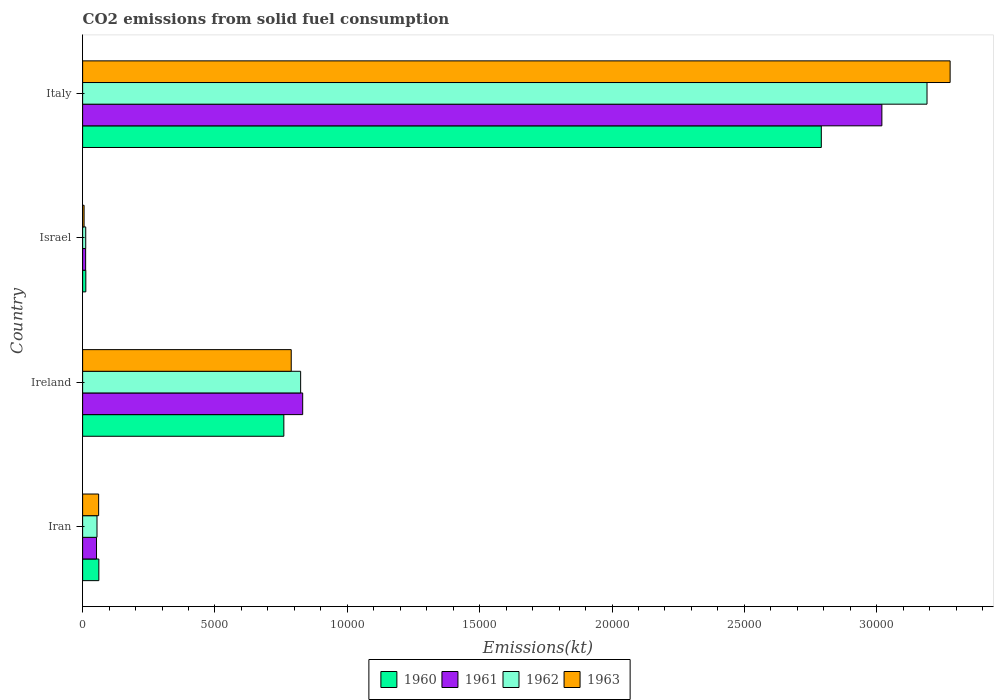How many groups of bars are there?
Your answer should be compact. 4. How many bars are there on the 3rd tick from the top?
Provide a short and direct response. 4. How many bars are there on the 1st tick from the bottom?
Provide a succinct answer. 4. In how many cases, is the number of bars for a given country not equal to the number of legend labels?
Provide a short and direct response. 0. What is the amount of CO2 emitted in 1961 in Ireland?
Make the answer very short. 8313.09. Across all countries, what is the maximum amount of CO2 emitted in 1961?
Offer a terse response. 3.02e+04. Across all countries, what is the minimum amount of CO2 emitted in 1963?
Your answer should be compact. 55.01. What is the total amount of CO2 emitted in 1963 in the graph?
Make the answer very short. 4.13e+04. What is the difference between the amount of CO2 emitted in 1963 in Ireland and that in Israel?
Keep it short and to the point. 7825.38. What is the difference between the amount of CO2 emitted in 1960 in Ireland and the amount of CO2 emitted in 1962 in Israel?
Offer a very short reply. 7484.35. What is the average amount of CO2 emitted in 1963 per country?
Provide a short and direct response. 1.03e+04. What is the difference between the amount of CO2 emitted in 1961 and amount of CO2 emitted in 1963 in Ireland?
Make the answer very short. 432.71. What is the ratio of the amount of CO2 emitted in 1961 in Iran to that in Israel?
Ensure brevity in your answer.  4.61. Is the amount of CO2 emitted in 1960 in Iran less than that in Israel?
Offer a very short reply. No. What is the difference between the highest and the second highest amount of CO2 emitted in 1962?
Ensure brevity in your answer.  2.37e+04. What is the difference between the highest and the lowest amount of CO2 emitted in 1962?
Keep it short and to the point. 3.18e+04. In how many countries, is the amount of CO2 emitted in 1962 greater than the average amount of CO2 emitted in 1962 taken over all countries?
Your answer should be compact. 1. Is the sum of the amount of CO2 emitted in 1961 in Israel and Italy greater than the maximum amount of CO2 emitted in 1962 across all countries?
Your answer should be compact. No. How many bars are there?
Give a very brief answer. 16. What is the difference between two consecutive major ticks on the X-axis?
Keep it short and to the point. 5000. Does the graph contain grids?
Give a very brief answer. No. Where does the legend appear in the graph?
Your answer should be very brief. Bottom center. How many legend labels are there?
Your answer should be very brief. 4. What is the title of the graph?
Keep it short and to the point. CO2 emissions from solid fuel consumption. Does "2013" appear as one of the legend labels in the graph?
Offer a very short reply. No. What is the label or title of the X-axis?
Provide a short and direct response. Emissions(kt). What is the Emissions(kt) in 1960 in Iran?
Your answer should be compact. 612.39. What is the Emissions(kt) in 1961 in Iran?
Your response must be concise. 524.38. What is the Emissions(kt) of 1962 in Iran?
Provide a short and direct response. 542.72. What is the Emissions(kt) in 1963 in Iran?
Keep it short and to the point. 605.05. What is the Emissions(kt) of 1960 in Ireland?
Offer a very short reply. 7601.69. What is the Emissions(kt) of 1961 in Ireland?
Your answer should be compact. 8313.09. What is the Emissions(kt) of 1962 in Ireland?
Your answer should be very brief. 8236.08. What is the Emissions(kt) of 1963 in Ireland?
Provide a short and direct response. 7880.38. What is the Emissions(kt) in 1960 in Israel?
Provide a succinct answer. 121.01. What is the Emissions(kt) of 1961 in Israel?
Provide a succinct answer. 113.68. What is the Emissions(kt) in 1962 in Israel?
Your answer should be very brief. 117.34. What is the Emissions(kt) of 1963 in Israel?
Your response must be concise. 55.01. What is the Emissions(kt) in 1960 in Italy?
Your answer should be very brief. 2.79e+04. What is the Emissions(kt) of 1961 in Italy?
Offer a terse response. 3.02e+04. What is the Emissions(kt) in 1962 in Italy?
Ensure brevity in your answer.  3.19e+04. What is the Emissions(kt) of 1963 in Italy?
Offer a terse response. 3.28e+04. Across all countries, what is the maximum Emissions(kt) of 1960?
Your answer should be compact. 2.79e+04. Across all countries, what is the maximum Emissions(kt) in 1961?
Give a very brief answer. 3.02e+04. Across all countries, what is the maximum Emissions(kt) in 1962?
Provide a succinct answer. 3.19e+04. Across all countries, what is the maximum Emissions(kt) of 1963?
Keep it short and to the point. 3.28e+04. Across all countries, what is the minimum Emissions(kt) in 1960?
Ensure brevity in your answer.  121.01. Across all countries, what is the minimum Emissions(kt) in 1961?
Your answer should be very brief. 113.68. Across all countries, what is the minimum Emissions(kt) of 1962?
Offer a terse response. 117.34. Across all countries, what is the minimum Emissions(kt) of 1963?
Your answer should be compact. 55.01. What is the total Emissions(kt) in 1960 in the graph?
Provide a succinct answer. 3.62e+04. What is the total Emissions(kt) in 1961 in the graph?
Ensure brevity in your answer.  3.91e+04. What is the total Emissions(kt) of 1962 in the graph?
Make the answer very short. 4.08e+04. What is the total Emissions(kt) of 1963 in the graph?
Your answer should be very brief. 4.13e+04. What is the difference between the Emissions(kt) of 1960 in Iran and that in Ireland?
Your response must be concise. -6989.3. What is the difference between the Emissions(kt) of 1961 in Iran and that in Ireland?
Ensure brevity in your answer.  -7788.71. What is the difference between the Emissions(kt) of 1962 in Iran and that in Ireland?
Make the answer very short. -7693.37. What is the difference between the Emissions(kt) of 1963 in Iran and that in Ireland?
Give a very brief answer. -7275.33. What is the difference between the Emissions(kt) in 1960 in Iran and that in Israel?
Ensure brevity in your answer.  491.38. What is the difference between the Emissions(kt) of 1961 in Iran and that in Israel?
Ensure brevity in your answer.  410.7. What is the difference between the Emissions(kt) of 1962 in Iran and that in Israel?
Your answer should be compact. 425.37. What is the difference between the Emissions(kt) in 1963 in Iran and that in Israel?
Your answer should be very brief. 550.05. What is the difference between the Emissions(kt) of 1960 in Iran and that in Italy?
Your response must be concise. -2.73e+04. What is the difference between the Emissions(kt) of 1961 in Iran and that in Italy?
Ensure brevity in your answer.  -2.97e+04. What is the difference between the Emissions(kt) of 1962 in Iran and that in Italy?
Offer a terse response. -3.14e+04. What is the difference between the Emissions(kt) of 1963 in Iran and that in Italy?
Provide a succinct answer. -3.22e+04. What is the difference between the Emissions(kt) in 1960 in Ireland and that in Israel?
Give a very brief answer. 7480.68. What is the difference between the Emissions(kt) in 1961 in Ireland and that in Israel?
Keep it short and to the point. 8199.41. What is the difference between the Emissions(kt) of 1962 in Ireland and that in Israel?
Give a very brief answer. 8118.74. What is the difference between the Emissions(kt) of 1963 in Ireland and that in Israel?
Your response must be concise. 7825.38. What is the difference between the Emissions(kt) of 1960 in Ireland and that in Italy?
Ensure brevity in your answer.  -2.03e+04. What is the difference between the Emissions(kt) in 1961 in Ireland and that in Italy?
Keep it short and to the point. -2.19e+04. What is the difference between the Emissions(kt) of 1962 in Ireland and that in Italy?
Offer a terse response. -2.37e+04. What is the difference between the Emissions(kt) in 1963 in Ireland and that in Italy?
Offer a very short reply. -2.49e+04. What is the difference between the Emissions(kt) in 1960 in Israel and that in Italy?
Your answer should be compact. -2.78e+04. What is the difference between the Emissions(kt) of 1961 in Israel and that in Italy?
Make the answer very short. -3.01e+04. What is the difference between the Emissions(kt) in 1962 in Israel and that in Italy?
Make the answer very short. -3.18e+04. What is the difference between the Emissions(kt) in 1963 in Israel and that in Italy?
Provide a short and direct response. -3.27e+04. What is the difference between the Emissions(kt) in 1960 in Iran and the Emissions(kt) in 1961 in Ireland?
Your answer should be compact. -7700.7. What is the difference between the Emissions(kt) in 1960 in Iran and the Emissions(kt) in 1962 in Ireland?
Make the answer very short. -7623.69. What is the difference between the Emissions(kt) in 1960 in Iran and the Emissions(kt) in 1963 in Ireland?
Make the answer very short. -7267.99. What is the difference between the Emissions(kt) of 1961 in Iran and the Emissions(kt) of 1962 in Ireland?
Provide a short and direct response. -7711.7. What is the difference between the Emissions(kt) in 1961 in Iran and the Emissions(kt) in 1963 in Ireland?
Ensure brevity in your answer.  -7356. What is the difference between the Emissions(kt) of 1962 in Iran and the Emissions(kt) of 1963 in Ireland?
Your response must be concise. -7337.67. What is the difference between the Emissions(kt) of 1960 in Iran and the Emissions(kt) of 1961 in Israel?
Offer a terse response. 498.71. What is the difference between the Emissions(kt) of 1960 in Iran and the Emissions(kt) of 1962 in Israel?
Provide a succinct answer. 495.05. What is the difference between the Emissions(kt) of 1960 in Iran and the Emissions(kt) of 1963 in Israel?
Your answer should be very brief. 557.38. What is the difference between the Emissions(kt) in 1961 in Iran and the Emissions(kt) in 1962 in Israel?
Ensure brevity in your answer.  407.04. What is the difference between the Emissions(kt) of 1961 in Iran and the Emissions(kt) of 1963 in Israel?
Ensure brevity in your answer.  469.38. What is the difference between the Emissions(kt) in 1962 in Iran and the Emissions(kt) in 1963 in Israel?
Offer a very short reply. 487.71. What is the difference between the Emissions(kt) of 1960 in Iran and the Emissions(kt) of 1961 in Italy?
Your response must be concise. -2.96e+04. What is the difference between the Emissions(kt) in 1960 in Iran and the Emissions(kt) in 1962 in Italy?
Provide a short and direct response. -3.13e+04. What is the difference between the Emissions(kt) in 1960 in Iran and the Emissions(kt) in 1963 in Italy?
Ensure brevity in your answer.  -3.22e+04. What is the difference between the Emissions(kt) in 1961 in Iran and the Emissions(kt) in 1962 in Italy?
Keep it short and to the point. -3.14e+04. What is the difference between the Emissions(kt) of 1961 in Iran and the Emissions(kt) of 1963 in Italy?
Give a very brief answer. -3.22e+04. What is the difference between the Emissions(kt) of 1962 in Iran and the Emissions(kt) of 1963 in Italy?
Your answer should be compact. -3.22e+04. What is the difference between the Emissions(kt) of 1960 in Ireland and the Emissions(kt) of 1961 in Israel?
Your answer should be very brief. 7488.01. What is the difference between the Emissions(kt) of 1960 in Ireland and the Emissions(kt) of 1962 in Israel?
Offer a very short reply. 7484.35. What is the difference between the Emissions(kt) in 1960 in Ireland and the Emissions(kt) in 1963 in Israel?
Give a very brief answer. 7546.69. What is the difference between the Emissions(kt) of 1961 in Ireland and the Emissions(kt) of 1962 in Israel?
Offer a terse response. 8195.75. What is the difference between the Emissions(kt) in 1961 in Ireland and the Emissions(kt) in 1963 in Israel?
Provide a succinct answer. 8258.08. What is the difference between the Emissions(kt) in 1962 in Ireland and the Emissions(kt) in 1963 in Israel?
Your response must be concise. 8181.08. What is the difference between the Emissions(kt) in 1960 in Ireland and the Emissions(kt) in 1961 in Italy?
Offer a very short reply. -2.26e+04. What is the difference between the Emissions(kt) of 1960 in Ireland and the Emissions(kt) of 1962 in Italy?
Your response must be concise. -2.43e+04. What is the difference between the Emissions(kt) of 1960 in Ireland and the Emissions(kt) of 1963 in Italy?
Keep it short and to the point. -2.52e+04. What is the difference between the Emissions(kt) of 1961 in Ireland and the Emissions(kt) of 1962 in Italy?
Provide a succinct answer. -2.36e+04. What is the difference between the Emissions(kt) in 1961 in Ireland and the Emissions(kt) in 1963 in Italy?
Your response must be concise. -2.45e+04. What is the difference between the Emissions(kt) of 1962 in Ireland and the Emissions(kt) of 1963 in Italy?
Your answer should be compact. -2.45e+04. What is the difference between the Emissions(kt) in 1960 in Israel and the Emissions(kt) in 1961 in Italy?
Your response must be concise. -3.01e+04. What is the difference between the Emissions(kt) of 1960 in Israel and the Emissions(kt) of 1962 in Italy?
Your answer should be compact. -3.18e+04. What is the difference between the Emissions(kt) in 1960 in Israel and the Emissions(kt) in 1963 in Italy?
Your response must be concise. -3.27e+04. What is the difference between the Emissions(kt) of 1961 in Israel and the Emissions(kt) of 1962 in Italy?
Ensure brevity in your answer.  -3.18e+04. What is the difference between the Emissions(kt) of 1961 in Israel and the Emissions(kt) of 1963 in Italy?
Provide a short and direct response. -3.27e+04. What is the difference between the Emissions(kt) in 1962 in Israel and the Emissions(kt) in 1963 in Italy?
Provide a short and direct response. -3.27e+04. What is the average Emissions(kt) in 1960 per country?
Give a very brief answer. 9060.24. What is the average Emissions(kt) in 1961 per country?
Your response must be concise. 9786.31. What is the average Emissions(kt) in 1962 per country?
Provide a short and direct response. 1.02e+04. What is the average Emissions(kt) of 1963 per country?
Your response must be concise. 1.03e+04. What is the difference between the Emissions(kt) of 1960 and Emissions(kt) of 1961 in Iran?
Provide a succinct answer. 88.01. What is the difference between the Emissions(kt) in 1960 and Emissions(kt) in 1962 in Iran?
Your answer should be very brief. 69.67. What is the difference between the Emissions(kt) in 1960 and Emissions(kt) in 1963 in Iran?
Offer a terse response. 7.33. What is the difference between the Emissions(kt) in 1961 and Emissions(kt) in 1962 in Iran?
Ensure brevity in your answer.  -18.34. What is the difference between the Emissions(kt) in 1961 and Emissions(kt) in 1963 in Iran?
Ensure brevity in your answer.  -80.67. What is the difference between the Emissions(kt) in 1962 and Emissions(kt) in 1963 in Iran?
Offer a very short reply. -62.34. What is the difference between the Emissions(kt) in 1960 and Emissions(kt) in 1961 in Ireland?
Offer a very short reply. -711.4. What is the difference between the Emissions(kt) in 1960 and Emissions(kt) in 1962 in Ireland?
Offer a very short reply. -634.39. What is the difference between the Emissions(kt) in 1960 and Emissions(kt) in 1963 in Ireland?
Provide a succinct answer. -278.69. What is the difference between the Emissions(kt) of 1961 and Emissions(kt) of 1962 in Ireland?
Provide a short and direct response. 77.01. What is the difference between the Emissions(kt) of 1961 and Emissions(kt) of 1963 in Ireland?
Offer a very short reply. 432.71. What is the difference between the Emissions(kt) of 1962 and Emissions(kt) of 1963 in Ireland?
Make the answer very short. 355.7. What is the difference between the Emissions(kt) of 1960 and Emissions(kt) of 1961 in Israel?
Provide a succinct answer. 7.33. What is the difference between the Emissions(kt) in 1960 and Emissions(kt) in 1962 in Israel?
Your answer should be compact. 3.67. What is the difference between the Emissions(kt) in 1960 and Emissions(kt) in 1963 in Israel?
Make the answer very short. 66.01. What is the difference between the Emissions(kt) of 1961 and Emissions(kt) of 1962 in Israel?
Provide a succinct answer. -3.67. What is the difference between the Emissions(kt) in 1961 and Emissions(kt) in 1963 in Israel?
Provide a succinct answer. 58.67. What is the difference between the Emissions(kt) of 1962 and Emissions(kt) of 1963 in Israel?
Offer a very short reply. 62.34. What is the difference between the Emissions(kt) in 1960 and Emissions(kt) in 1961 in Italy?
Your answer should be very brief. -2288.21. What is the difference between the Emissions(kt) in 1960 and Emissions(kt) in 1962 in Italy?
Offer a terse response. -3993.36. What is the difference between the Emissions(kt) in 1960 and Emissions(kt) in 1963 in Italy?
Offer a very short reply. -4866.11. What is the difference between the Emissions(kt) of 1961 and Emissions(kt) of 1962 in Italy?
Your answer should be compact. -1705.15. What is the difference between the Emissions(kt) in 1961 and Emissions(kt) in 1963 in Italy?
Ensure brevity in your answer.  -2577.9. What is the difference between the Emissions(kt) in 1962 and Emissions(kt) in 1963 in Italy?
Offer a terse response. -872.75. What is the ratio of the Emissions(kt) in 1960 in Iran to that in Ireland?
Offer a very short reply. 0.08. What is the ratio of the Emissions(kt) in 1961 in Iran to that in Ireland?
Your answer should be very brief. 0.06. What is the ratio of the Emissions(kt) of 1962 in Iran to that in Ireland?
Your answer should be very brief. 0.07. What is the ratio of the Emissions(kt) in 1963 in Iran to that in Ireland?
Offer a terse response. 0.08. What is the ratio of the Emissions(kt) of 1960 in Iran to that in Israel?
Provide a succinct answer. 5.06. What is the ratio of the Emissions(kt) of 1961 in Iran to that in Israel?
Offer a very short reply. 4.61. What is the ratio of the Emissions(kt) of 1962 in Iran to that in Israel?
Give a very brief answer. 4.62. What is the ratio of the Emissions(kt) in 1960 in Iran to that in Italy?
Provide a succinct answer. 0.02. What is the ratio of the Emissions(kt) in 1961 in Iran to that in Italy?
Keep it short and to the point. 0.02. What is the ratio of the Emissions(kt) in 1962 in Iran to that in Italy?
Offer a terse response. 0.02. What is the ratio of the Emissions(kt) of 1963 in Iran to that in Italy?
Offer a very short reply. 0.02. What is the ratio of the Emissions(kt) of 1960 in Ireland to that in Israel?
Your answer should be very brief. 62.82. What is the ratio of the Emissions(kt) in 1961 in Ireland to that in Israel?
Your answer should be compact. 73.13. What is the ratio of the Emissions(kt) in 1962 in Ireland to that in Israel?
Give a very brief answer. 70.19. What is the ratio of the Emissions(kt) in 1963 in Ireland to that in Israel?
Your response must be concise. 143.27. What is the ratio of the Emissions(kt) in 1960 in Ireland to that in Italy?
Your response must be concise. 0.27. What is the ratio of the Emissions(kt) in 1961 in Ireland to that in Italy?
Your answer should be very brief. 0.28. What is the ratio of the Emissions(kt) in 1962 in Ireland to that in Italy?
Ensure brevity in your answer.  0.26. What is the ratio of the Emissions(kt) in 1963 in Ireland to that in Italy?
Provide a succinct answer. 0.24. What is the ratio of the Emissions(kt) of 1960 in Israel to that in Italy?
Give a very brief answer. 0. What is the ratio of the Emissions(kt) in 1961 in Israel to that in Italy?
Make the answer very short. 0. What is the ratio of the Emissions(kt) in 1962 in Israel to that in Italy?
Provide a short and direct response. 0. What is the ratio of the Emissions(kt) in 1963 in Israel to that in Italy?
Provide a short and direct response. 0. What is the difference between the highest and the second highest Emissions(kt) in 1960?
Your answer should be compact. 2.03e+04. What is the difference between the highest and the second highest Emissions(kt) in 1961?
Give a very brief answer. 2.19e+04. What is the difference between the highest and the second highest Emissions(kt) of 1962?
Ensure brevity in your answer.  2.37e+04. What is the difference between the highest and the second highest Emissions(kt) in 1963?
Give a very brief answer. 2.49e+04. What is the difference between the highest and the lowest Emissions(kt) in 1960?
Keep it short and to the point. 2.78e+04. What is the difference between the highest and the lowest Emissions(kt) of 1961?
Ensure brevity in your answer.  3.01e+04. What is the difference between the highest and the lowest Emissions(kt) in 1962?
Ensure brevity in your answer.  3.18e+04. What is the difference between the highest and the lowest Emissions(kt) in 1963?
Ensure brevity in your answer.  3.27e+04. 